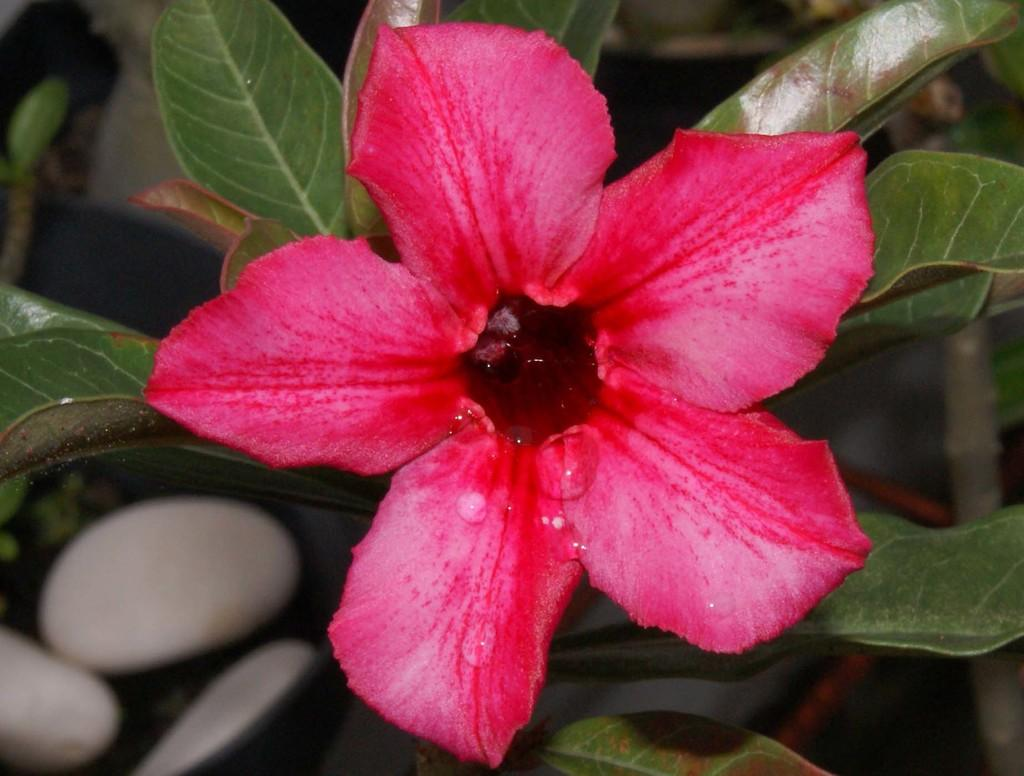What color is the flower in the image? The flower in the image is pink. Where is the flower located? The flower is on a plant. What can be observed about the background of the image? The background of the image is blurred. What is the profit made from the flower in the image? There is no information about profit in the image, as it only shows a pink flower on a plant with a blurred background. 